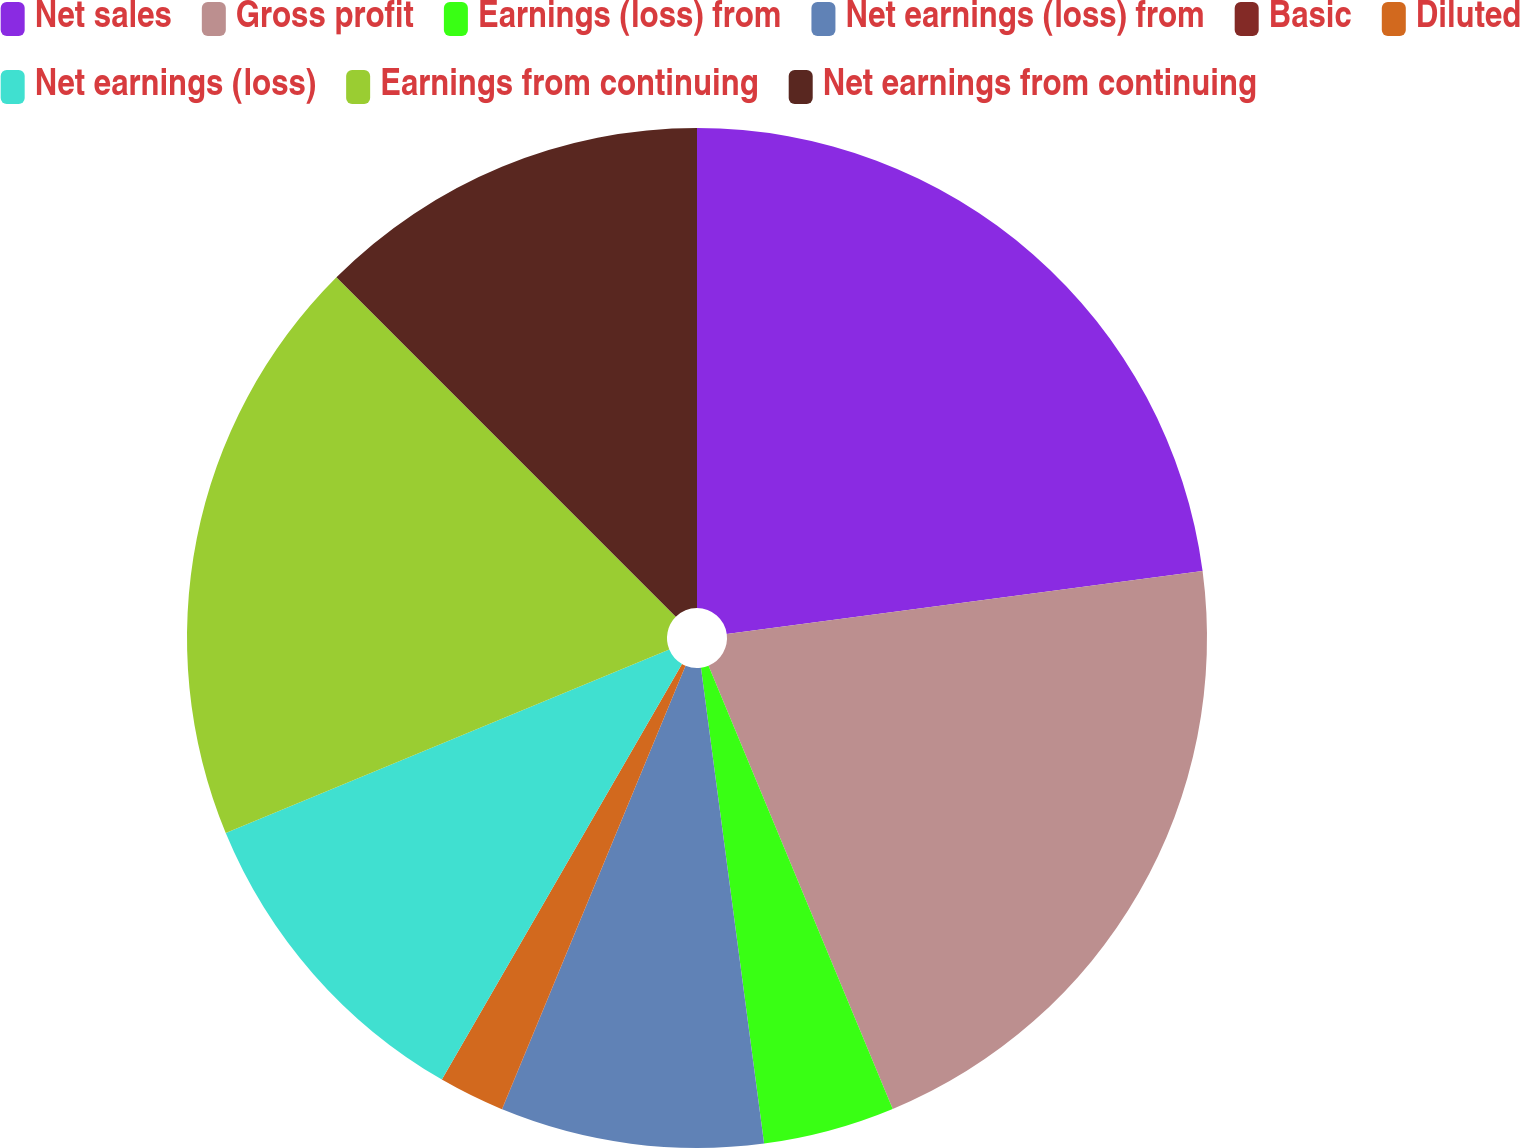Convert chart. <chart><loc_0><loc_0><loc_500><loc_500><pie_chart><fcel>Net sales<fcel>Gross profit<fcel>Earnings (loss) from<fcel>Net earnings (loss) from<fcel>Basic<fcel>Diluted<fcel>Net earnings (loss)<fcel>Earnings from continuing<fcel>Net earnings from continuing<nl><fcel>22.91%<fcel>20.83%<fcel>4.17%<fcel>8.34%<fcel>0.01%<fcel>2.09%<fcel>10.42%<fcel>18.75%<fcel>12.5%<nl></chart> 